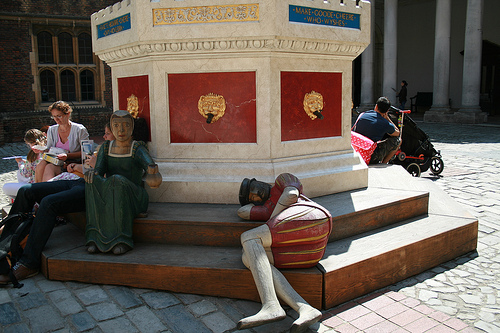<image>
Is there a man to the left of the woman? No. The man is not to the left of the woman. From this viewpoint, they have a different horizontal relationship. 